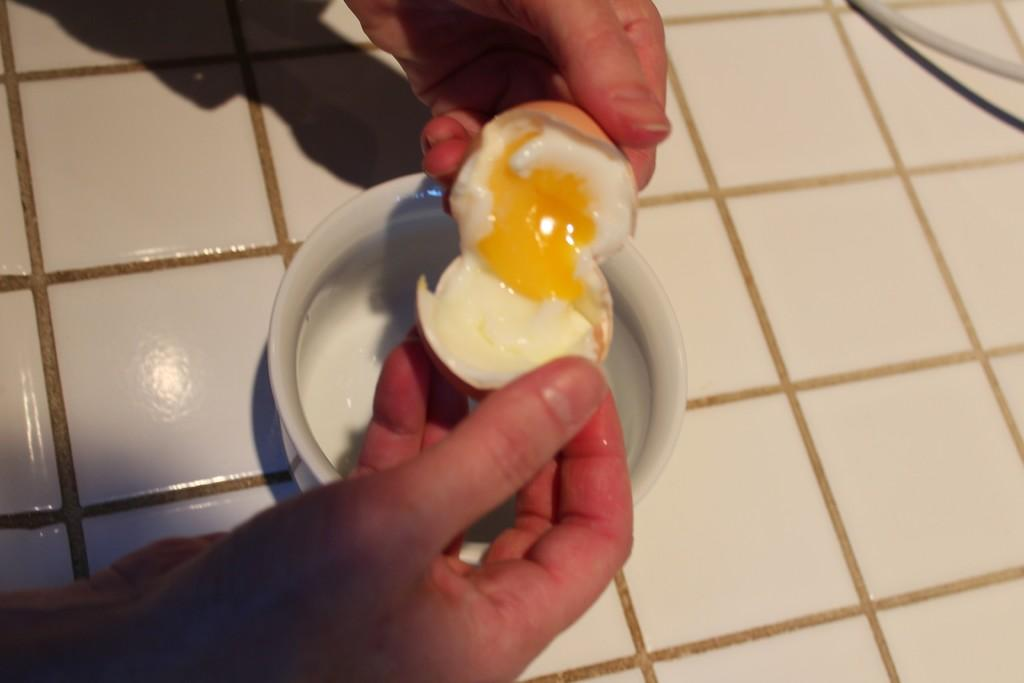What is being held by the human hands in the image? There are human hands holding an egg in the image. What part of the egg is visible in the image? There is egg yolk visible in the image. What type of flooring can be seen in the image? There is a marble floor in the image. What object can be seen in the image that is made of metal? There is a wire in the image. What type of pest can be seen crawling on the marble floor in the image? There are no pests visible in the image; it only shows human hands holding an egg, egg yolk, and a wire. 